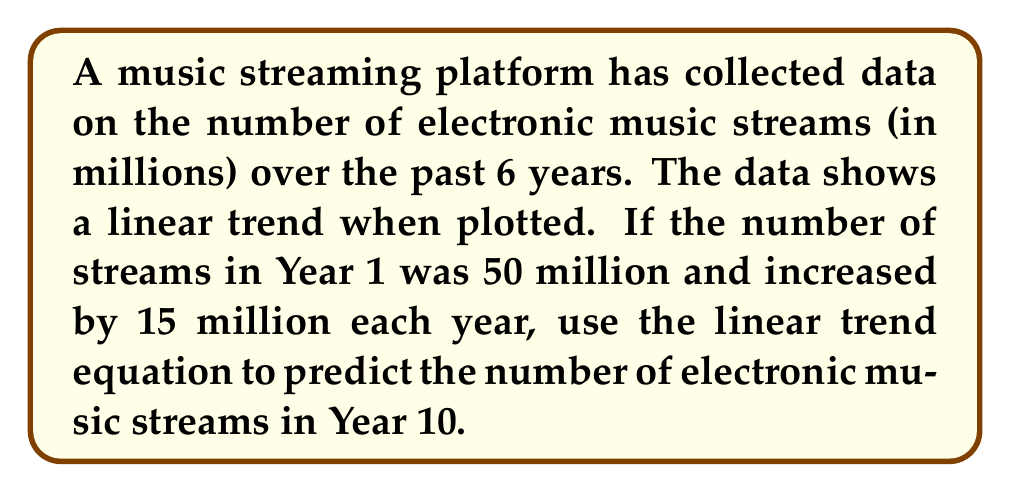Can you answer this question? To solve this problem, we'll use the linear trend equation for time series analysis:

$$Y_t = b_0 + b_1t$$

Where:
$Y_t$ is the predicted value at time $t$
$b_0$ is the y-intercept (initial value)
$b_1$ is the slope (rate of change per unit time)
$t$ is the time period

Given:
- Initial value (Year 1): $b_0 = 50$ million
- Annual increase: $b_1 = 15$ million
- We want to predict for Year 10, so $t = 10$

Steps:
1. Substitute the values into the linear trend equation:
   $$Y_t = 50 + 15t$$

2. Calculate the prediction for Year 10 by setting $t = 10$:
   $$Y_{10} = 50 + 15(10)$$
   $$Y_{10} = 50 + 150$$
   $$Y_{10} = 200$$

Therefore, the predicted number of electronic music streams in Year 10 is 200 million.
Answer: 200 million streams 